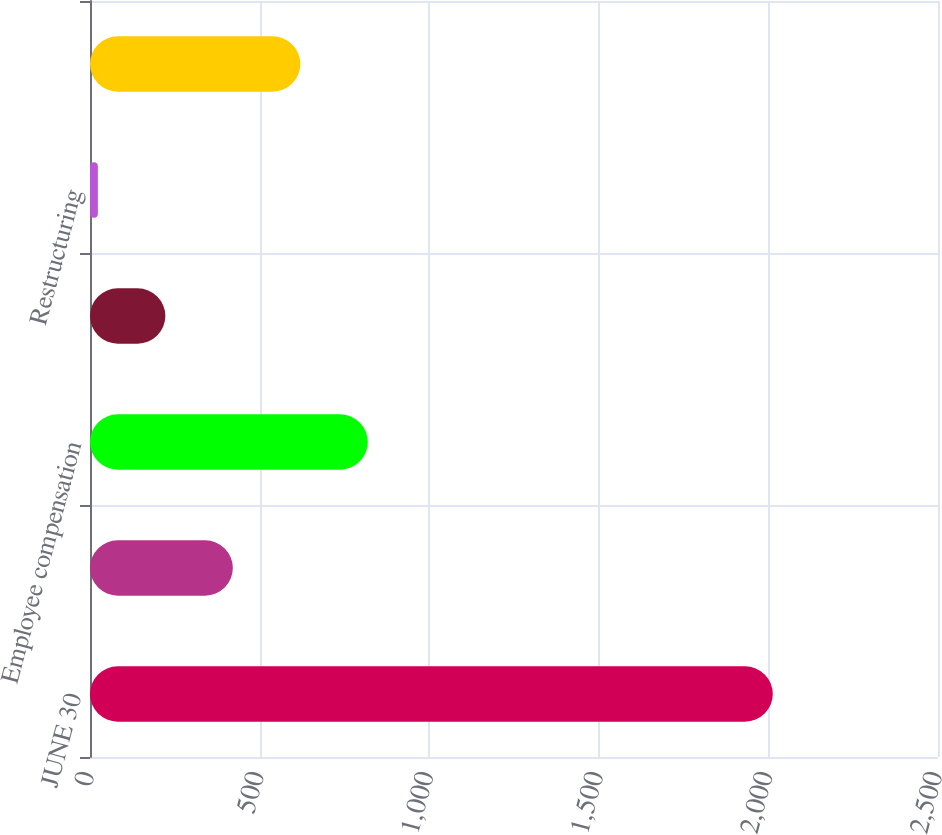Convert chart to OTSL. <chart><loc_0><loc_0><loc_500><loc_500><bar_chart><fcel>JUNE 30<fcel>Advertising merchandising and<fcel>Employee compensation<fcel>Payroll and other taxes<fcel>Restructuring<fcel>Other<nl><fcel>2013<fcel>421.16<fcel>819.12<fcel>222.18<fcel>23.2<fcel>620.14<nl></chart> 